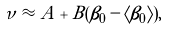<formula> <loc_0><loc_0><loc_500><loc_500>\nu \approx A + B ( \beta _ { 0 } - \langle \beta _ { 0 } \rangle ) ,</formula> 